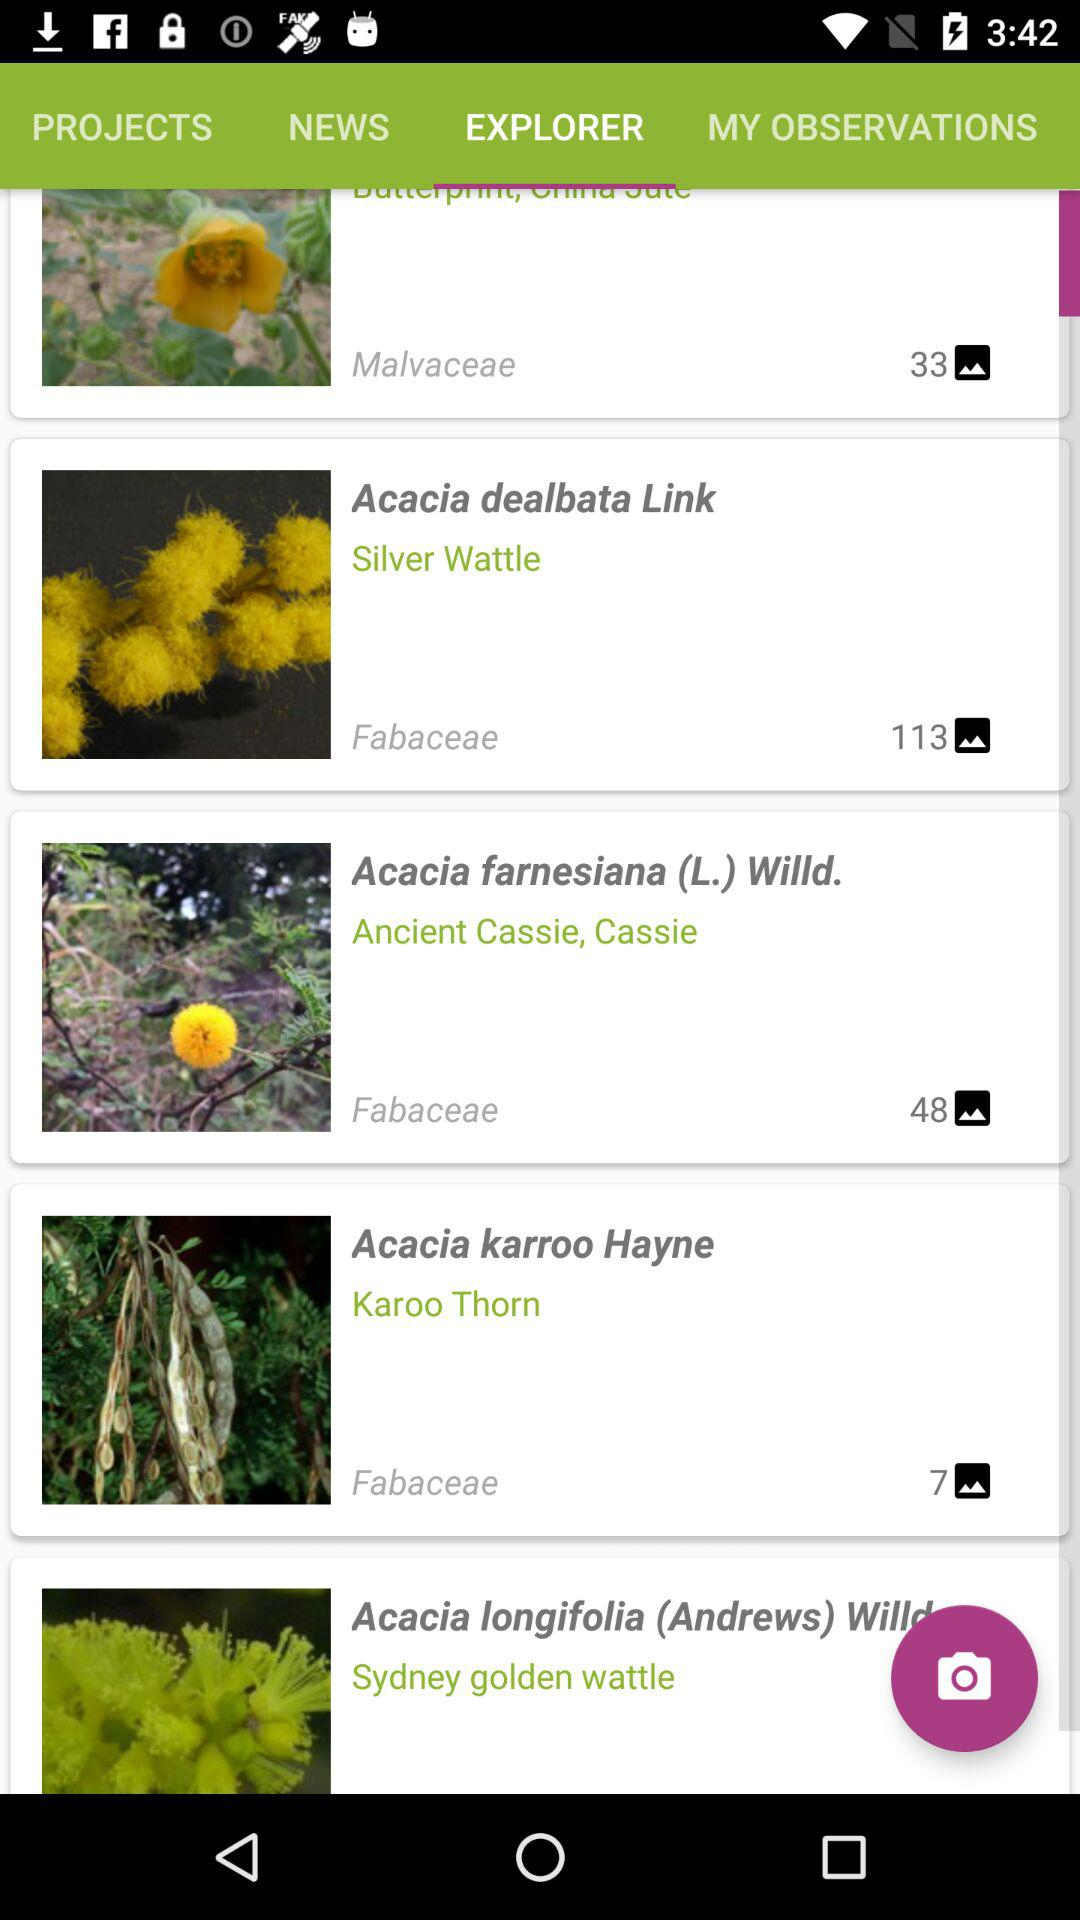How many pictures in the "Acacia dealbata Link"? There are 113 pictures. 